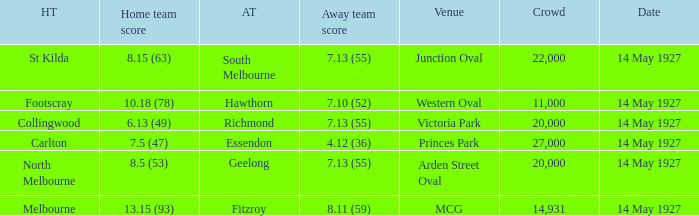Which venue hosted a home team with a score of 13.15 (93)? MCG. 